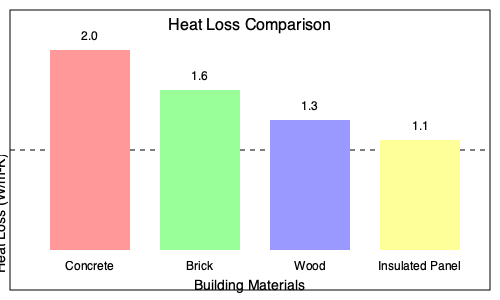As a school principal looking to improve energy efficiency, you're presented with the heat loss diagram above showing the U-values (thermal transmittance) of various building materials. If you need to retrofit an existing concrete structure, which material would provide the greatest improvement in energy efficiency, and by what percentage would it reduce heat loss compared to concrete? To solve this problem, we need to follow these steps:

1. Identify the U-values for each material from the graph:
   - Concrete: 2.0 W/m²K
   - Brick: 1.6 W/m²K
   - Wood: 1.3 W/m²K
   - Insulated Panel: 1.1 W/m²K

2. Determine which material has the lowest U-value:
   The insulated panel has the lowest U-value at 1.1 W/m²K, indicating the best thermal performance.

3. Calculate the percentage reduction in heat loss:
   - Original heat loss (concrete): 2.0 W/m²K
   - New heat loss (insulated panel): 1.1 W/m²K
   - Reduction in heat loss: 2.0 - 1.1 = 0.9 W/m²K

   Percentage reduction:
   $$\frac{\text{Reduction}}{\text{Original}} \times 100 = \frac{0.9}{2.0} \times 100 = 45\%$$

Therefore, replacing concrete with insulated panels would reduce heat loss by 45%.
Answer: Insulated panels; 45% reduction 